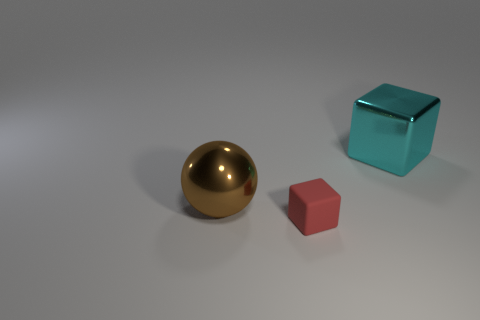There is a red block; does it have the same size as the metal object that is on the left side of the large cyan metal object?
Your answer should be very brief. No. What color is the metallic object to the left of the tiny red object right of the big metallic sphere?
Provide a succinct answer. Brown. Is the cyan object the same size as the matte block?
Provide a succinct answer. No. What is the color of the thing that is both to the left of the big cyan metallic object and behind the small red block?
Offer a very short reply. Brown. What size is the metallic ball?
Offer a terse response. Large. Is the number of large cyan cubes that are on the right side of the cyan metallic block greater than the number of brown things on the right side of the small rubber cube?
Make the answer very short. No. Are there more large brown metal balls than small cyan balls?
Provide a short and direct response. Yes. There is a object that is left of the large block and right of the brown shiny thing; what size is it?
Your answer should be very brief. Small. What is the shape of the large cyan metallic thing?
Provide a succinct answer. Cube. Is there any other thing that has the same size as the red matte thing?
Your answer should be compact. No. 